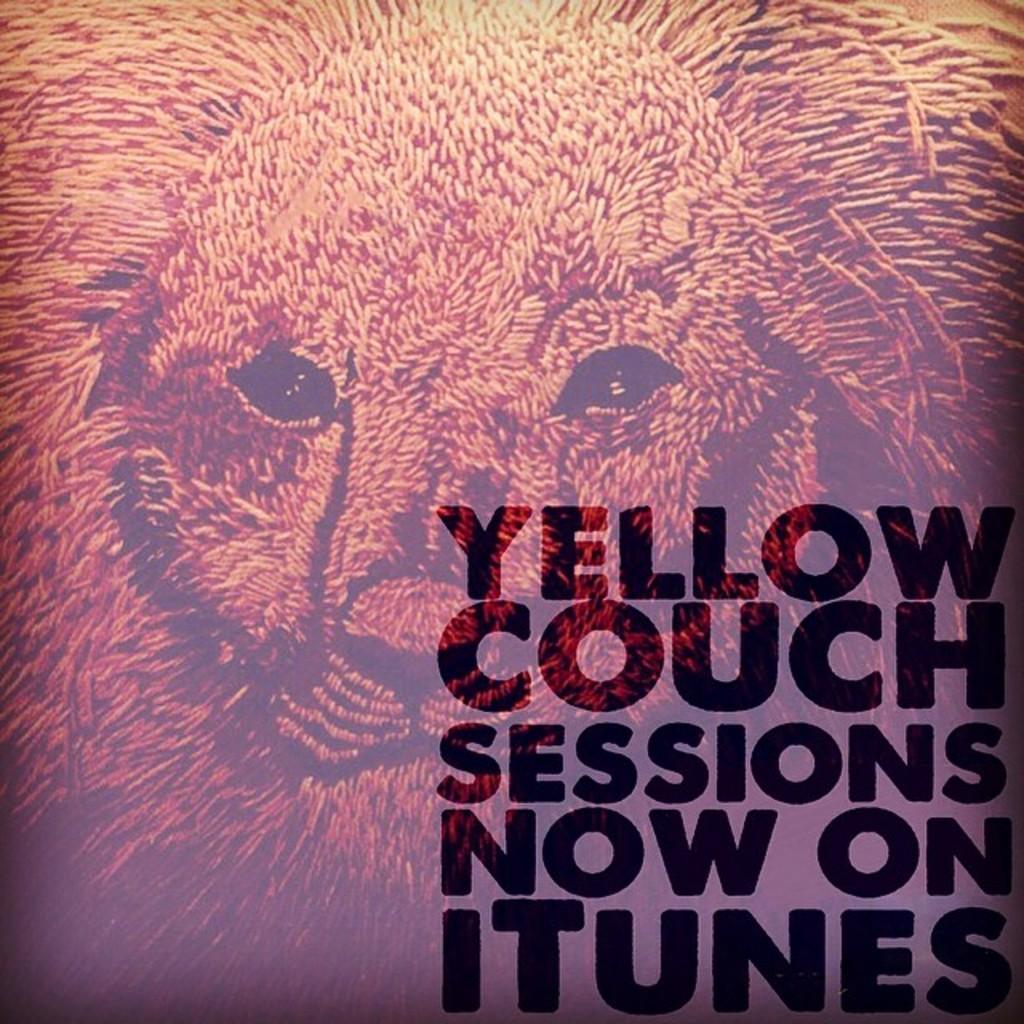Describe this image in one or two sentences. In center of the image we can see a watermark of a lion. At the bottom there is grass. 